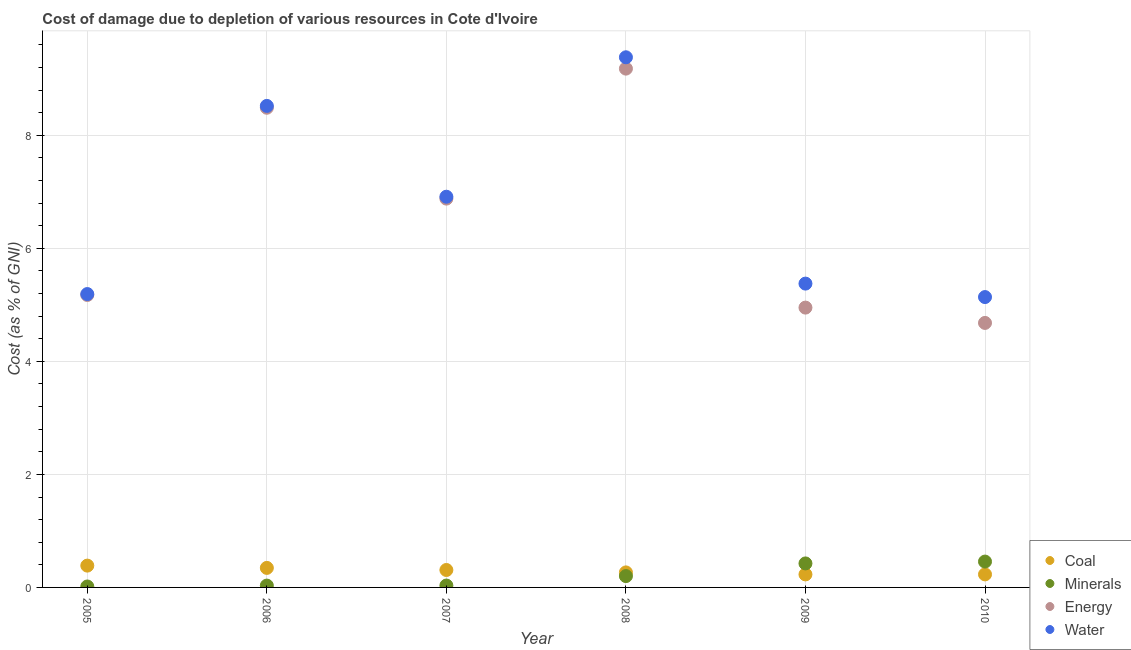What is the cost of damage due to depletion of coal in 2006?
Make the answer very short. 0.35. Across all years, what is the maximum cost of damage due to depletion of energy?
Offer a very short reply. 9.18. Across all years, what is the minimum cost of damage due to depletion of coal?
Offer a very short reply. 0.23. In which year was the cost of damage due to depletion of energy minimum?
Provide a succinct answer. 2010. What is the total cost of damage due to depletion of energy in the graph?
Keep it short and to the point. 39.35. What is the difference between the cost of damage due to depletion of minerals in 2006 and that in 2007?
Your answer should be compact. -0. What is the difference between the cost of damage due to depletion of energy in 2009 and the cost of damage due to depletion of water in 2005?
Offer a terse response. -0.24. What is the average cost of damage due to depletion of energy per year?
Give a very brief answer. 6.56. In the year 2009, what is the difference between the cost of damage due to depletion of water and cost of damage due to depletion of coal?
Your response must be concise. 5.15. In how many years, is the cost of damage due to depletion of energy greater than 4.4 %?
Your response must be concise. 6. What is the ratio of the cost of damage due to depletion of coal in 2008 to that in 2009?
Make the answer very short. 1.15. Is the cost of damage due to depletion of coal in 2005 less than that in 2006?
Your response must be concise. No. Is the difference between the cost of damage due to depletion of energy in 2005 and 2009 greater than the difference between the cost of damage due to depletion of water in 2005 and 2009?
Provide a succinct answer. Yes. What is the difference between the highest and the second highest cost of damage due to depletion of energy?
Give a very brief answer. 0.69. What is the difference between the highest and the lowest cost of damage due to depletion of coal?
Provide a succinct answer. 0.16. Is it the case that in every year, the sum of the cost of damage due to depletion of energy and cost of damage due to depletion of water is greater than the sum of cost of damage due to depletion of coal and cost of damage due to depletion of minerals?
Make the answer very short. No. Is it the case that in every year, the sum of the cost of damage due to depletion of coal and cost of damage due to depletion of minerals is greater than the cost of damage due to depletion of energy?
Provide a succinct answer. No. Does the cost of damage due to depletion of water monotonically increase over the years?
Keep it short and to the point. No. Is the cost of damage due to depletion of coal strictly less than the cost of damage due to depletion of minerals over the years?
Make the answer very short. No. How many years are there in the graph?
Your answer should be compact. 6. Are the values on the major ticks of Y-axis written in scientific E-notation?
Your response must be concise. No. Does the graph contain any zero values?
Provide a succinct answer. No. Where does the legend appear in the graph?
Keep it short and to the point. Bottom right. What is the title of the graph?
Your answer should be compact. Cost of damage due to depletion of various resources in Cote d'Ivoire . Does "Interest Payments" appear as one of the legend labels in the graph?
Keep it short and to the point. No. What is the label or title of the Y-axis?
Ensure brevity in your answer.  Cost (as % of GNI). What is the Cost (as % of GNI) of Coal in 2005?
Provide a succinct answer. 0.39. What is the Cost (as % of GNI) of Minerals in 2005?
Your answer should be compact. 0.02. What is the Cost (as % of GNI) in Energy in 2005?
Offer a very short reply. 5.17. What is the Cost (as % of GNI) of Water in 2005?
Your answer should be compact. 5.19. What is the Cost (as % of GNI) of Coal in 2006?
Provide a succinct answer. 0.35. What is the Cost (as % of GNI) in Minerals in 2006?
Your answer should be very brief. 0.03. What is the Cost (as % of GNI) in Energy in 2006?
Your answer should be compact. 8.49. What is the Cost (as % of GNI) of Water in 2006?
Make the answer very short. 8.52. What is the Cost (as % of GNI) of Coal in 2007?
Keep it short and to the point. 0.31. What is the Cost (as % of GNI) of Minerals in 2007?
Your answer should be compact. 0.03. What is the Cost (as % of GNI) of Energy in 2007?
Ensure brevity in your answer.  6.88. What is the Cost (as % of GNI) in Water in 2007?
Offer a very short reply. 6.91. What is the Cost (as % of GNI) of Coal in 2008?
Provide a short and direct response. 0.27. What is the Cost (as % of GNI) in Minerals in 2008?
Give a very brief answer. 0.2. What is the Cost (as % of GNI) of Energy in 2008?
Make the answer very short. 9.18. What is the Cost (as % of GNI) of Water in 2008?
Your answer should be very brief. 9.38. What is the Cost (as % of GNI) of Coal in 2009?
Give a very brief answer. 0.23. What is the Cost (as % of GNI) of Minerals in 2009?
Your answer should be compact. 0.42. What is the Cost (as % of GNI) of Energy in 2009?
Keep it short and to the point. 4.95. What is the Cost (as % of GNI) in Water in 2009?
Provide a short and direct response. 5.38. What is the Cost (as % of GNI) of Coal in 2010?
Offer a terse response. 0.23. What is the Cost (as % of GNI) of Minerals in 2010?
Ensure brevity in your answer.  0.46. What is the Cost (as % of GNI) in Energy in 2010?
Offer a terse response. 4.68. What is the Cost (as % of GNI) in Water in 2010?
Ensure brevity in your answer.  5.14. Across all years, what is the maximum Cost (as % of GNI) in Coal?
Give a very brief answer. 0.39. Across all years, what is the maximum Cost (as % of GNI) in Minerals?
Give a very brief answer. 0.46. Across all years, what is the maximum Cost (as % of GNI) of Energy?
Offer a terse response. 9.18. Across all years, what is the maximum Cost (as % of GNI) of Water?
Make the answer very short. 9.38. Across all years, what is the minimum Cost (as % of GNI) of Coal?
Offer a very short reply. 0.23. Across all years, what is the minimum Cost (as % of GNI) in Minerals?
Offer a terse response. 0.02. Across all years, what is the minimum Cost (as % of GNI) of Energy?
Your answer should be compact. 4.68. Across all years, what is the minimum Cost (as % of GNI) in Water?
Your response must be concise. 5.14. What is the total Cost (as % of GNI) in Coal in the graph?
Provide a succinct answer. 1.77. What is the total Cost (as % of GNI) in Minerals in the graph?
Provide a succinct answer. 1.17. What is the total Cost (as % of GNI) of Energy in the graph?
Keep it short and to the point. 39.35. What is the total Cost (as % of GNI) in Water in the graph?
Make the answer very short. 40.52. What is the difference between the Cost (as % of GNI) of Coal in 2005 and that in 2006?
Make the answer very short. 0.04. What is the difference between the Cost (as % of GNI) of Minerals in 2005 and that in 2006?
Make the answer very short. -0.02. What is the difference between the Cost (as % of GNI) in Energy in 2005 and that in 2006?
Offer a terse response. -3.31. What is the difference between the Cost (as % of GNI) of Water in 2005 and that in 2006?
Provide a short and direct response. -3.33. What is the difference between the Cost (as % of GNI) of Coal in 2005 and that in 2007?
Make the answer very short. 0.08. What is the difference between the Cost (as % of GNI) of Minerals in 2005 and that in 2007?
Keep it short and to the point. -0.02. What is the difference between the Cost (as % of GNI) of Energy in 2005 and that in 2007?
Provide a succinct answer. -1.71. What is the difference between the Cost (as % of GNI) in Water in 2005 and that in 2007?
Your response must be concise. -1.72. What is the difference between the Cost (as % of GNI) of Coal in 2005 and that in 2008?
Make the answer very short. 0.12. What is the difference between the Cost (as % of GNI) of Minerals in 2005 and that in 2008?
Make the answer very short. -0.18. What is the difference between the Cost (as % of GNI) in Energy in 2005 and that in 2008?
Your answer should be compact. -4.01. What is the difference between the Cost (as % of GNI) of Water in 2005 and that in 2008?
Offer a very short reply. -4.19. What is the difference between the Cost (as % of GNI) of Coal in 2005 and that in 2009?
Give a very brief answer. 0.16. What is the difference between the Cost (as % of GNI) in Minerals in 2005 and that in 2009?
Your answer should be very brief. -0.41. What is the difference between the Cost (as % of GNI) of Energy in 2005 and that in 2009?
Your answer should be very brief. 0.22. What is the difference between the Cost (as % of GNI) in Water in 2005 and that in 2009?
Offer a very short reply. -0.18. What is the difference between the Cost (as % of GNI) in Coal in 2005 and that in 2010?
Keep it short and to the point. 0.16. What is the difference between the Cost (as % of GNI) of Minerals in 2005 and that in 2010?
Keep it short and to the point. -0.44. What is the difference between the Cost (as % of GNI) in Energy in 2005 and that in 2010?
Your response must be concise. 0.49. What is the difference between the Cost (as % of GNI) in Water in 2005 and that in 2010?
Provide a succinct answer. 0.05. What is the difference between the Cost (as % of GNI) of Coal in 2006 and that in 2007?
Offer a terse response. 0.04. What is the difference between the Cost (as % of GNI) in Minerals in 2006 and that in 2007?
Your answer should be very brief. -0. What is the difference between the Cost (as % of GNI) in Energy in 2006 and that in 2007?
Offer a very short reply. 1.61. What is the difference between the Cost (as % of GNI) in Water in 2006 and that in 2007?
Ensure brevity in your answer.  1.61. What is the difference between the Cost (as % of GNI) of Coal in 2006 and that in 2008?
Offer a terse response. 0.08. What is the difference between the Cost (as % of GNI) in Minerals in 2006 and that in 2008?
Ensure brevity in your answer.  -0.17. What is the difference between the Cost (as % of GNI) of Energy in 2006 and that in 2008?
Your response must be concise. -0.69. What is the difference between the Cost (as % of GNI) in Water in 2006 and that in 2008?
Your answer should be compact. -0.86. What is the difference between the Cost (as % of GNI) in Coal in 2006 and that in 2009?
Your response must be concise. 0.12. What is the difference between the Cost (as % of GNI) in Minerals in 2006 and that in 2009?
Ensure brevity in your answer.  -0.39. What is the difference between the Cost (as % of GNI) of Energy in 2006 and that in 2009?
Keep it short and to the point. 3.54. What is the difference between the Cost (as % of GNI) of Water in 2006 and that in 2009?
Your answer should be very brief. 3.14. What is the difference between the Cost (as % of GNI) of Coal in 2006 and that in 2010?
Keep it short and to the point. 0.11. What is the difference between the Cost (as % of GNI) of Minerals in 2006 and that in 2010?
Give a very brief answer. -0.42. What is the difference between the Cost (as % of GNI) of Energy in 2006 and that in 2010?
Your response must be concise. 3.81. What is the difference between the Cost (as % of GNI) in Water in 2006 and that in 2010?
Offer a terse response. 3.38. What is the difference between the Cost (as % of GNI) of Coal in 2007 and that in 2008?
Your answer should be compact. 0.04. What is the difference between the Cost (as % of GNI) of Minerals in 2007 and that in 2008?
Ensure brevity in your answer.  -0.17. What is the difference between the Cost (as % of GNI) in Energy in 2007 and that in 2008?
Your answer should be compact. -2.3. What is the difference between the Cost (as % of GNI) in Water in 2007 and that in 2008?
Keep it short and to the point. -2.47. What is the difference between the Cost (as % of GNI) of Coal in 2007 and that in 2009?
Offer a terse response. 0.08. What is the difference between the Cost (as % of GNI) of Minerals in 2007 and that in 2009?
Keep it short and to the point. -0.39. What is the difference between the Cost (as % of GNI) of Energy in 2007 and that in 2009?
Make the answer very short. 1.93. What is the difference between the Cost (as % of GNI) of Water in 2007 and that in 2009?
Your response must be concise. 1.54. What is the difference between the Cost (as % of GNI) of Coal in 2007 and that in 2010?
Provide a succinct answer. 0.08. What is the difference between the Cost (as % of GNI) of Minerals in 2007 and that in 2010?
Make the answer very short. -0.42. What is the difference between the Cost (as % of GNI) of Energy in 2007 and that in 2010?
Keep it short and to the point. 2.2. What is the difference between the Cost (as % of GNI) of Water in 2007 and that in 2010?
Offer a terse response. 1.78. What is the difference between the Cost (as % of GNI) in Coal in 2008 and that in 2009?
Offer a very short reply. 0.04. What is the difference between the Cost (as % of GNI) in Minerals in 2008 and that in 2009?
Your answer should be very brief. -0.22. What is the difference between the Cost (as % of GNI) of Energy in 2008 and that in 2009?
Provide a succinct answer. 4.23. What is the difference between the Cost (as % of GNI) of Water in 2008 and that in 2009?
Offer a terse response. 4. What is the difference between the Cost (as % of GNI) of Coal in 2008 and that in 2010?
Offer a very short reply. 0.04. What is the difference between the Cost (as % of GNI) in Minerals in 2008 and that in 2010?
Your answer should be compact. -0.26. What is the difference between the Cost (as % of GNI) of Energy in 2008 and that in 2010?
Make the answer very short. 4.5. What is the difference between the Cost (as % of GNI) of Water in 2008 and that in 2010?
Make the answer very short. 4.24. What is the difference between the Cost (as % of GNI) in Coal in 2009 and that in 2010?
Your answer should be very brief. -0. What is the difference between the Cost (as % of GNI) in Minerals in 2009 and that in 2010?
Give a very brief answer. -0.03. What is the difference between the Cost (as % of GNI) of Energy in 2009 and that in 2010?
Your answer should be compact. 0.27. What is the difference between the Cost (as % of GNI) in Water in 2009 and that in 2010?
Your answer should be very brief. 0.24. What is the difference between the Cost (as % of GNI) of Coal in 2005 and the Cost (as % of GNI) of Minerals in 2006?
Your answer should be compact. 0.35. What is the difference between the Cost (as % of GNI) in Coal in 2005 and the Cost (as % of GNI) in Energy in 2006?
Keep it short and to the point. -8.1. What is the difference between the Cost (as % of GNI) of Coal in 2005 and the Cost (as % of GNI) of Water in 2006?
Provide a short and direct response. -8.13. What is the difference between the Cost (as % of GNI) of Minerals in 2005 and the Cost (as % of GNI) of Energy in 2006?
Give a very brief answer. -8.47. What is the difference between the Cost (as % of GNI) in Minerals in 2005 and the Cost (as % of GNI) in Water in 2006?
Offer a very short reply. -8.5. What is the difference between the Cost (as % of GNI) of Energy in 2005 and the Cost (as % of GNI) of Water in 2006?
Offer a very short reply. -3.35. What is the difference between the Cost (as % of GNI) in Coal in 2005 and the Cost (as % of GNI) in Minerals in 2007?
Your answer should be compact. 0.35. What is the difference between the Cost (as % of GNI) in Coal in 2005 and the Cost (as % of GNI) in Energy in 2007?
Make the answer very short. -6.49. What is the difference between the Cost (as % of GNI) in Coal in 2005 and the Cost (as % of GNI) in Water in 2007?
Ensure brevity in your answer.  -6.53. What is the difference between the Cost (as % of GNI) in Minerals in 2005 and the Cost (as % of GNI) in Energy in 2007?
Provide a short and direct response. -6.86. What is the difference between the Cost (as % of GNI) in Minerals in 2005 and the Cost (as % of GNI) in Water in 2007?
Provide a short and direct response. -6.9. What is the difference between the Cost (as % of GNI) in Energy in 2005 and the Cost (as % of GNI) in Water in 2007?
Give a very brief answer. -1.74. What is the difference between the Cost (as % of GNI) of Coal in 2005 and the Cost (as % of GNI) of Minerals in 2008?
Provide a succinct answer. 0.19. What is the difference between the Cost (as % of GNI) in Coal in 2005 and the Cost (as % of GNI) in Energy in 2008?
Offer a terse response. -8.79. What is the difference between the Cost (as % of GNI) of Coal in 2005 and the Cost (as % of GNI) of Water in 2008?
Give a very brief answer. -8.99. What is the difference between the Cost (as % of GNI) of Minerals in 2005 and the Cost (as % of GNI) of Energy in 2008?
Your response must be concise. -9.16. What is the difference between the Cost (as % of GNI) in Minerals in 2005 and the Cost (as % of GNI) in Water in 2008?
Your answer should be compact. -9.36. What is the difference between the Cost (as % of GNI) in Energy in 2005 and the Cost (as % of GNI) in Water in 2008?
Offer a terse response. -4.21. What is the difference between the Cost (as % of GNI) of Coal in 2005 and the Cost (as % of GNI) of Minerals in 2009?
Your answer should be compact. -0.04. What is the difference between the Cost (as % of GNI) of Coal in 2005 and the Cost (as % of GNI) of Energy in 2009?
Offer a terse response. -4.57. What is the difference between the Cost (as % of GNI) of Coal in 2005 and the Cost (as % of GNI) of Water in 2009?
Provide a succinct answer. -4.99. What is the difference between the Cost (as % of GNI) of Minerals in 2005 and the Cost (as % of GNI) of Energy in 2009?
Your response must be concise. -4.93. What is the difference between the Cost (as % of GNI) in Minerals in 2005 and the Cost (as % of GNI) in Water in 2009?
Your answer should be compact. -5.36. What is the difference between the Cost (as % of GNI) of Energy in 2005 and the Cost (as % of GNI) of Water in 2009?
Give a very brief answer. -0.2. What is the difference between the Cost (as % of GNI) of Coal in 2005 and the Cost (as % of GNI) of Minerals in 2010?
Your answer should be compact. -0.07. What is the difference between the Cost (as % of GNI) in Coal in 2005 and the Cost (as % of GNI) in Energy in 2010?
Make the answer very short. -4.29. What is the difference between the Cost (as % of GNI) of Coal in 2005 and the Cost (as % of GNI) of Water in 2010?
Keep it short and to the point. -4.75. What is the difference between the Cost (as % of GNI) of Minerals in 2005 and the Cost (as % of GNI) of Energy in 2010?
Make the answer very short. -4.66. What is the difference between the Cost (as % of GNI) of Minerals in 2005 and the Cost (as % of GNI) of Water in 2010?
Your answer should be very brief. -5.12. What is the difference between the Cost (as % of GNI) of Energy in 2005 and the Cost (as % of GNI) of Water in 2010?
Your answer should be compact. 0.04. What is the difference between the Cost (as % of GNI) of Coal in 2006 and the Cost (as % of GNI) of Minerals in 2007?
Provide a short and direct response. 0.31. What is the difference between the Cost (as % of GNI) in Coal in 2006 and the Cost (as % of GNI) in Energy in 2007?
Provide a short and direct response. -6.53. What is the difference between the Cost (as % of GNI) of Coal in 2006 and the Cost (as % of GNI) of Water in 2007?
Your answer should be very brief. -6.57. What is the difference between the Cost (as % of GNI) of Minerals in 2006 and the Cost (as % of GNI) of Energy in 2007?
Your response must be concise. -6.85. What is the difference between the Cost (as % of GNI) of Minerals in 2006 and the Cost (as % of GNI) of Water in 2007?
Keep it short and to the point. -6.88. What is the difference between the Cost (as % of GNI) of Energy in 2006 and the Cost (as % of GNI) of Water in 2007?
Your response must be concise. 1.57. What is the difference between the Cost (as % of GNI) of Coal in 2006 and the Cost (as % of GNI) of Minerals in 2008?
Make the answer very short. 0.14. What is the difference between the Cost (as % of GNI) of Coal in 2006 and the Cost (as % of GNI) of Energy in 2008?
Offer a very short reply. -8.83. What is the difference between the Cost (as % of GNI) of Coal in 2006 and the Cost (as % of GNI) of Water in 2008?
Give a very brief answer. -9.04. What is the difference between the Cost (as % of GNI) of Minerals in 2006 and the Cost (as % of GNI) of Energy in 2008?
Your response must be concise. -9.15. What is the difference between the Cost (as % of GNI) of Minerals in 2006 and the Cost (as % of GNI) of Water in 2008?
Provide a succinct answer. -9.35. What is the difference between the Cost (as % of GNI) of Energy in 2006 and the Cost (as % of GNI) of Water in 2008?
Offer a terse response. -0.89. What is the difference between the Cost (as % of GNI) in Coal in 2006 and the Cost (as % of GNI) in Minerals in 2009?
Keep it short and to the point. -0.08. What is the difference between the Cost (as % of GNI) of Coal in 2006 and the Cost (as % of GNI) of Energy in 2009?
Offer a terse response. -4.61. What is the difference between the Cost (as % of GNI) of Coal in 2006 and the Cost (as % of GNI) of Water in 2009?
Keep it short and to the point. -5.03. What is the difference between the Cost (as % of GNI) of Minerals in 2006 and the Cost (as % of GNI) of Energy in 2009?
Your answer should be compact. -4.92. What is the difference between the Cost (as % of GNI) in Minerals in 2006 and the Cost (as % of GNI) in Water in 2009?
Give a very brief answer. -5.34. What is the difference between the Cost (as % of GNI) of Energy in 2006 and the Cost (as % of GNI) of Water in 2009?
Offer a terse response. 3.11. What is the difference between the Cost (as % of GNI) in Coal in 2006 and the Cost (as % of GNI) in Minerals in 2010?
Provide a succinct answer. -0.11. What is the difference between the Cost (as % of GNI) of Coal in 2006 and the Cost (as % of GNI) of Energy in 2010?
Your answer should be compact. -4.33. What is the difference between the Cost (as % of GNI) in Coal in 2006 and the Cost (as % of GNI) in Water in 2010?
Offer a terse response. -4.79. What is the difference between the Cost (as % of GNI) of Minerals in 2006 and the Cost (as % of GNI) of Energy in 2010?
Keep it short and to the point. -4.65. What is the difference between the Cost (as % of GNI) of Minerals in 2006 and the Cost (as % of GNI) of Water in 2010?
Offer a terse response. -5.11. What is the difference between the Cost (as % of GNI) in Energy in 2006 and the Cost (as % of GNI) in Water in 2010?
Provide a succinct answer. 3.35. What is the difference between the Cost (as % of GNI) of Coal in 2007 and the Cost (as % of GNI) of Minerals in 2008?
Provide a short and direct response. 0.11. What is the difference between the Cost (as % of GNI) of Coal in 2007 and the Cost (as % of GNI) of Energy in 2008?
Your response must be concise. -8.87. What is the difference between the Cost (as % of GNI) of Coal in 2007 and the Cost (as % of GNI) of Water in 2008?
Make the answer very short. -9.07. What is the difference between the Cost (as % of GNI) in Minerals in 2007 and the Cost (as % of GNI) in Energy in 2008?
Your answer should be very brief. -9.15. What is the difference between the Cost (as % of GNI) in Minerals in 2007 and the Cost (as % of GNI) in Water in 2008?
Provide a short and direct response. -9.35. What is the difference between the Cost (as % of GNI) of Energy in 2007 and the Cost (as % of GNI) of Water in 2008?
Offer a terse response. -2.5. What is the difference between the Cost (as % of GNI) of Coal in 2007 and the Cost (as % of GNI) of Minerals in 2009?
Keep it short and to the point. -0.12. What is the difference between the Cost (as % of GNI) in Coal in 2007 and the Cost (as % of GNI) in Energy in 2009?
Keep it short and to the point. -4.64. What is the difference between the Cost (as % of GNI) of Coal in 2007 and the Cost (as % of GNI) of Water in 2009?
Offer a terse response. -5.07. What is the difference between the Cost (as % of GNI) of Minerals in 2007 and the Cost (as % of GNI) of Energy in 2009?
Offer a terse response. -4.92. What is the difference between the Cost (as % of GNI) of Minerals in 2007 and the Cost (as % of GNI) of Water in 2009?
Keep it short and to the point. -5.34. What is the difference between the Cost (as % of GNI) in Energy in 2007 and the Cost (as % of GNI) in Water in 2009?
Make the answer very short. 1.5. What is the difference between the Cost (as % of GNI) in Coal in 2007 and the Cost (as % of GNI) in Minerals in 2010?
Keep it short and to the point. -0.15. What is the difference between the Cost (as % of GNI) of Coal in 2007 and the Cost (as % of GNI) of Energy in 2010?
Your answer should be compact. -4.37. What is the difference between the Cost (as % of GNI) in Coal in 2007 and the Cost (as % of GNI) in Water in 2010?
Make the answer very short. -4.83. What is the difference between the Cost (as % of GNI) in Minerals in 2007 and the Cost (as % of GNI) in Energy in 2010?
Keep it short and to the point. -4.65. What is the difference between the Cost (as % of GNI) of Minerals in 2007 and the Cost (as % of GNI) of Water in 2010?
Offer a terse response. -5.1. What is the difference between the Cost (as % of GNI) in Energy in 2007 and the Cost (as % of GNI) in Water in 2010?
Keep it short and to the point. 1.74. What is the difference between the Cost (as % of GNI) in Coal in 2008 and the Cost (as % of GNI) in Minerals in 2009?
Offer a terse response. -0.16. What is the difference between the Cost (as % of GNI) of Coal in 2008 and the Cost (as % of GNI) of Energy in 2009?
Give a very brief answer. -4.69. What is the difference between the Cost (as % of GNI) of Coal in 2008 and the Cost (as % of GNI) of Water in 2009?
Your response must be concise. -5.11. What is the difference between the Cost (as % of GNI) in Minerals in 2008 and the Cost (as % of GNI) in Energy in 2009?
Give a very brief answer. -4.75. What is the difference between the Cost (as % of GNI) in Minerals in 2008 and the Cost (as % of GNI) in Water in 2009?
Make the answer very short. -5.18. What is the difference between the Cost (as % of GNI) of Energy in 2008 and the Cost (as % of GNI) of Water in 2009?
Offer a terse response. 3.8. What is the difference between the Cost (as % of GNI) of Coal in 2008 and the Cost (as % of GNI) of Minerals in 2010?
Your response must be concise. -0.19. What is the difference between the Cost (as % of GNI) of Coal in 2008 and the Cost (as % of GNI) of Energy in 2010?
Give a very brief answer. -4.41. What is the difference between the Cost (as % of GNI) of Coal in 2008 and the Cost (as % of GNI) of Water in 2010?
Your answer should be very brief. -4.87. What is the difference between the Cost (as % of GNI) in Minerals in 2008 and the Cost (as % of GNI) in Energy in 2010?
Offer a very short reply. -4.48. What is the difference between the Cost (as % of GNI) of Minerals in 2008 and the Cost (as % of GNI) of Water in 2010?
Your response must be concise. -4.94. What is the difference between the Cost (as % of GNI) in Energy in 2008 and the Cost (as % of GNI) in Water in 2010?
Provide a succinct answer. 4.04. What is the difference between the Cost (as % of GNI) of Coal in 2009 and the Cost (as % of GNI) of Minerals in 2010?
Your answer should be very brief. -0.23. What is the difference between the Cost (as % of GNI) of Coal in 2009 and the Cost (as % of GNI) of Energy in 2010?
Ensure brevity in your answer.  -4.45. What is the difference between the Cost (as % of GNI) of Coal in 2009 and the Cost (as % of GNI) of Water in 2010?
Provide a short and direct response. -4.91. What is the difference between the Cost (as % of GNI) of Minerals in 2009 and the Cost (as % of GNI) of Energy in 2010?
Your response must be concise. -4.26. What is the difference between the Cost (as % of GNI) of Minerals in 2009 and the Cost (as % of GNI) of Water in 2010?
Provide a short and direct response. -4.71. What is the difference between the Cost (as % of GNI) in Energy in 2009 and the Cost (as % of GNI) in Water in 2010?
Keep it short and to the point. -0.19. What is the average Cost (as % of GNI) of Coal per year?
Your answer should be compact. 0.29. What is the average Cost (as % of GNI) of Minerals per year?
Provide a succinct answer. 0.19. What is the average Cost (as % of GNI) of Energy per year?
Offer a terse response. 6.56. What is the average Cost (as % of GNI) of Water per year?
Your response must be concise. 6.75. In the year 2005, what is the difference between the Cost (as % of GNI) in Coal and Cost (as % of GNI) in Minerals?
Provide a succinct answer. 0.37. In the year 2005, what is the difference between the Cost (as % of GNI) of Coal and Cost (as % of GNI) of Energy?
Make the answer very short. -4.79. In the year 2005, what is the difference between the Cost (as % of GNI) of Coal and Cost (as % of GNI) of Water?
Ensure brevity in your answer.  -4.81. In the year 2005, what is the difference between the Cost (as % of GNI) in Minerals and Cost (as % of GNI) in Energy?
Keep it short and to the point. -5.16. In the year 2005, what is the difference between the Cost (as % of GNI) of Minerals and Cost (as % of GNI) of Water?
Ensure brevity in your answer.  -5.17. In the year 2005, what is the difference between the Cost (as % of GNI) in Energy and Cost (as % of GNI) in Water?
Your response must be concise. -0.02. In the year 2006, what is the difference between the Cost (as % of GNI) of Coal and Cost (as % of GNI) of Minerals?
Ensure brevity in your answer.  0.31. In the year 2006, what is the difference between the Cost (as % of GNI) in Coal and Cost (as % of GNI) in Energy?
Provide a succinct answer. -8.14. In the year 2006, what is the difference between the Cost (as % of GNI) of Coal and Cost (as % of GNI) of Water?
Your response must be concise. -8.18. In the year 2006, what is the difference between the Cost (as % of GNI) of Minerals and Cost (as % of GNI) of Energy?
Provide a short and direct response. -8.46. In the year 2006, what is the difference between the Cost (as % of GNI) of Minerals and Cost (as % of GNI) of Water?
Make the answer very short. -8.49. In the year 2006, what is the difference between the Cost (as % of GNI) in Energy and Cost (as % of GNI) in Water?
Your answer should be very brief. -0.03. In the year 2007, what is the difference between the Cost (as % of GNI) of Coal and Cost (as % of GNI) of Minerals?
Make the answer very short. 0.28. In the year 2007, what is the difference between the Cost (as % of GNI) of Coal and Cost (as % of GNI) of Energy?
Ensure brevity in your answer.  -6.57. In the year 2007, what is the difference between the Cost (as % of GNI) in Coal and Cost (as % of GNI) in Water?
Your answer should be very brief. -6.6. In the year 2007, what is the difference between the Cost (as % of GNI) of Minerals and Cost (as % of GNI) of Energy?
Your answer should be very brief. -6.85. In the year 2007, what is the difference between the Cost (as % of GNI) in Minerals and Cost (as % of GNI) in Water?
Keep it short and to the point. -6.88. In the year 2007, what is the difference between the Cost (as % of GNI) in Energy and Cost (as % of GNI) in Water?
Ensure brevity in your answer.  -0.03. In the year 2008, what is the difference between the Cost (as % of GNI) of Coal and Cost (as % of GNI) of Minerals?
Your answer should be very brief. 0.07. In the year 2008, what is the difference between the Cost (as % of GNI) of Coal and Cost (as % of GNI) of Energy?
Provide a succinct answer. -8.91. In the year 2008, what is the difference between the Cost (as % of GNI) in Coal and Cost (as % of GNI) in Water?
Offer a very short reply. -9.12. In the year 2008, what is the difference between the Cost (as % of GNI) in Minerals and Cost (as % of GNI) in Energy?
Give a very brief answer. -8.98. In the year 2008, what is the difference between the Cost (as % of GNI) of Minerals and Cost (as % of GNI) of Water?
Ensure brevity in your answer.  -9.18. In the year 2008, what is the difference between the Cost (as % of GNI) in Energy and Cost (as % of GNI) in Water?
Make the answer very short. -0.2. In the year 2009, what is the difference between the Cost (as % of GNI) of Coal and Cost (as % of GNI) of Minerals?
Your response must be concise. -0.19. In the year 2009, what is the difference between the Cost (as % of GNI) of Coal and Cost (as % of GNI) of Energy?
Provide a short and direct response. -4.72. In the year 2009, what is the difference between the Cost (as % of GNI) of Coal and Cost (as % of GNI) of Water?
Offer a terse response. -5.15. In the year 2009, what is the difference between the Cost (as % of GNI) of Minerals and Cost (as % of GNI) of Energy?
Ensure brevity in your answer.  -4.53. In the year 2009, what is the difference between the Cost (as % of GNI) of Minerals and Cost (as % of GNI) of Water?
Give a very brief answer. -4.95. In the year 2009, what is the difference between the Cost (as % of GNI) in Energy and Cost (as % of GNI) in Water?
Offer a terse response. -0.42. In the year 2010, what is the difference between the Cost (as % of GNI) of Coal and Cost (as % of GNI) of Minerals?
Your response must be concise. -0.23. In the year 2010, what is the difference between the Cost (as % of GNI) in Coal and Cost (as % of GNI) in Energy?
Keep it short and to the point. -4.45. In the year 2010, what is the difference between the Cost (as % of GNI) in Coal and Cost (as % of GNI) in Water?
Your answer should be very brief. -4.91. In the year 2010, what is the difference between the Cost (as % of GNI) of Minerals and Cost (as % of GNI) of Energy?
Your response must be concise. -4.22. In the year 2010, what is the difference between the Cost (as % of GNI) of Minerals and Cost (as % of GNI) of Water?
Give a very brief answer. -4.68. In the year 2010, what is the difference between the Cost (as % of GNI) of Energy and Cost (as % of GNI) of Water?
Your answer should be compact. -0.46. What is the ratio of the Cost (as % of GNI) of Coal in 2005 to that in 2006?
Your response must be concise. 1.12. What is the ratio of the Cost (as % of GNI) in Minerals in 2005 to that in 2006?
Provide a succinct answer. 0.51. What is the ratio of the Cost (as % of GNI) in Energy in 2005 to that in 2006?
Ensure brevity in your answer.  0.61. What is the ratio of the Cost (as % of GNI) in Water in 2005 to that in 2006?
Ensure brevity in your answer.  0.61. What is the ratio of the Cost (as % of GNI) of Coal in 2005 to that in 2007?
Offer a very short reply. 1.25. What is the ratio of the Cost (as % of GNI) in Minerals in 2005 to that in 2007?
Keep it short and to the point. 0.49. What is the ratio of the Cost (as % of GNI) of Energy in 2005 to that in 2007?
Your answer should be compact. 0.75. What is the ratio of the Cost (as % of GNI) of Water in 2005 to that in 2007?
Your answer should be compact. 0.75. What is the ratio of the Cost (as % of GNI) of Coal in 2005 to that in 2008?
Ensure brevity in your answer.  1.45. What is the ratio of the Cost (as % of GNI) of Minerals in 2005 to that in 2008?
Give a very brief answer. 0.08. What is the ratio of the Cost (as % of GNI) in Energy in 2005 to that in 2008?
Keep it short and to the point. 0.56. What is the ratio of the Cost (as % of GNI) of Water in 2005 to that in 2008?
Provide a succinct answer. 0.55. What is the ratio of the Cost (as % of GNI) of Coal in 2005 to that in 2009?
Your answer should be very brief. 1.67. What is the ratio of the Cost (as % of GNI) of Minerals in 2005 to that in 2009?
Provide a short and direct response. 0.04. What is the ratio of the Cost (as % of GNI) in Energy in 2005 to that in 2009?
Your response must be concise. 1.05. What is the ratio of the Cost (as % of GNI) of Water in 2005 to that in 2009?
Provide a short and direct response. 0.97. What is the ratio of the Cost (as % of GNI) in Coal in 2005 to that in 2010?
Your answer should be compact. 1.67. What is the ratio of the Cost (as % of GNI) of Minerals in 2005 to that in 2010?
Make the answer very short. 0.04. What is the ratio of the Cost (as % of GNI) of Energy in 2005 to that in 2010?
Make the answer very short. 1.11. What is the ratio of the Cost (as % of GNI) of Water in 2005 to that in 2010?
Offer a very short reply. 1.01. What is the ratio of the Cost (as % of GNI) of Coal in 2006 to that in 2007?
Keep it short and to the point. 1.12. What is the ratio of the Cost (as % of GNI) of Minerals in 2006 to that in 2007?
Provide a short and direct response. 0.97. What is the ratio of the Cost (as % of GNI) of Energy in 2006 to that in 2007?
Keep it short and to the point. 1.23. What is the ratio of the Cost (as % of GNI) of Water in 2006 to that in 2007?
Provide a short and direct response. 1.23. What is the ratio of the Cost (as % of GNI) in Coal in 2006 to that in 2008?
Your answer should be very brief. 1.3. What is the ratio of the Cost (as % of GNI) of Minerals in 2006 to that in 2008?
Provide a succinct answer. 0.16. What is the ratio of the Cost (as % of GNI) of Energy in 2006 to that in 2008?
Your answer should be very brief. 0.92. What is the ratio of the Cost (as % of GNI) of Water in 2006 to that in 2008?
Your answer should be very brief. 0.91. What is the ratio of the Cost (as % of GNI) in Coal in 2006 to that in 2009?
Ensure brevity in your answer.  1.5. What is the ratio of the Cost (as % of GNI) in Minerals in 2006 to that in 2009?
Make the answer very short. 0.08. What is the ratio of the Cost (as % of GNI) of Energy in 2006 to that in 2009?
Your answer should be very brief. 1.71. What is the ratio of the Cost (as % of GNI) of Water in 2006 to that in 2009?
Your response must be concise. 1.58. What is the ratio of the Cost (as % of GNI) of Coal in 2006 to that in 2010?
Make the answer very short. 1.5. What is the ratio of the Cost (as % of GNI) in Minerals in 2006 to that in 2010?
Provide a short and direct response. 0.07. What is the ratio of the Cost (as % of GNI) of Energy in 2006 to that in 2010?
Provide a short and direct response. 1.81. What is the ratio of the Cost (as % of GNI) in Water in 2006 to that in 2010?
Offer a very short reply. 1.66. What is the ratio of the Cost (as % of GNI) in Coal in 2007 to that in 2008?
Ensure brevity in your answer.  1.16. What is the ratio of the Cost (as % of GNI) in Minerals in 2007 to that in 2008?
Your answer should be very brief. 0.17. What is the ratio of the Cost (as % of GNI) of Energy in 2007 to that in 2008?
Offer a very short reply. 0.75. What is the ratio of the Cost (as % of GNI) of Water in 2007 to that in 2008?
Give a very brief answer. 0.74. What is the ratio of the Cost (as % of GNI) of Coal in 2007 to that in 2009?
Make the answer very short. 1.34. What is the ratio of the Cost (as % of GNI) in Minerals in 2007 to that in 2009?
Give a very brief answer. 0.08. What is the ratio of the Cost (as % of GNI) in Energy in 2007 to that in 2009?
Keep it short and to the point. 1.39. What is the ratio of the Cost (as % of GNI) in Water in 2007 to that in 2009?
Ensure brevity in your answer.  1.29. What is the ratio of the Cost (as % of GNI) in Coal in 2007 to that in 2010?
Your response must be concise. 1.34. What is the ratio of the Cost (as % of GNI) in Minerals in 2007 to that in 2010?
Offer a terse response. 0.07. What is the ratio of the Cost (as % of GNI) of Energy in 2007 to that in 2010?
Keep it short and to the point. 1.47. What is the ratio of the Cost (as % of GNI) in Water in 2007 to that in 2010?
Provide a short and direct response. 1.35. What is the ratio of the Cost (as % of GNI) in Coal in 2008 to that in 2009?
Offer a terse response. 1.15. What is the ratio of the Cost (as % of GNI) of Minerals in 2008 to that in 2009?
Ensure brevity in your answer.  0.47. What is the ratio of the Cost (as % of GNI) in Energy in 2008 to that in 2009?
Offer a very short reply. 1.85. What is the ratio of the Cost (as % of GNI) of Water in 2008 to that in 2009?
Offer a terse response. 1.74. What is the ratio of the Cost (as % of GNI) in Coal in 2008 to that in 2010?
Offer a very short reply. 1.15. What is the ratio of the Cost (as % of GNI) of Minerals in 2008 to that in 2010?
Provide a succinct answer. 0.44. What is the ratio of the Cost (as % of GNI) of Energy in 2008 to that in 2010?
Make the answer very short. 1.96. What is the ratio of the Cost (as % of GNI) of Water in 2008 to that in 2010?
Make the answer very short. 1.83. What is the ratio of the Cost (as % of GNI) in Coal in 2009 to that in 2010?
Your response must be concise. 1. What is the ratio of the Cost (as % of GNI) of Minerals in 2009 to that in 2010?
Your answer should be compact. 0.93. What is the ratio of the Cost (as % of GNI) in Energy in 2009 to that in 2010?
Your answer should be compact. 1.06. What is the ratio of the Cost (as % of GNI) of Water in 2009 to that in 2010?
Keep it short and to the point. 1.05. What is the difference between the highest and the second highest Cost (as % of GNI) of Coal?
Provide a succinct answer. 0.04. What is the difference between the highest and the second highest Cost (as % of GNI) in Minerals?
Offer a very short reply. 0.03. What is the difference between the highest and the second highest Cost (as % of GNI) of Energy?
Ensure brevity in your answer.  0.69. What is the difference between the highest and the second highest Cost (as % of GNI) of Water?
Give a very brief answer. 0.86. What is the difference between the highest and the lowest Cost (as % of GNI) in Coal?
Provide a succinct answer. 0.16. What is the difference between the highest and the lowest Cost (as % of GNI) in Minerals?
Keep it short and to the point. 0.44. What is the difference between the highest and the lowest Cost (as % of GNI) of Energy?
Keep it short and to the point. 4.5. What is the difference between the highest and the lowest Cost (as % of GNI) of Water?
Make the answer very short. 4.24. 